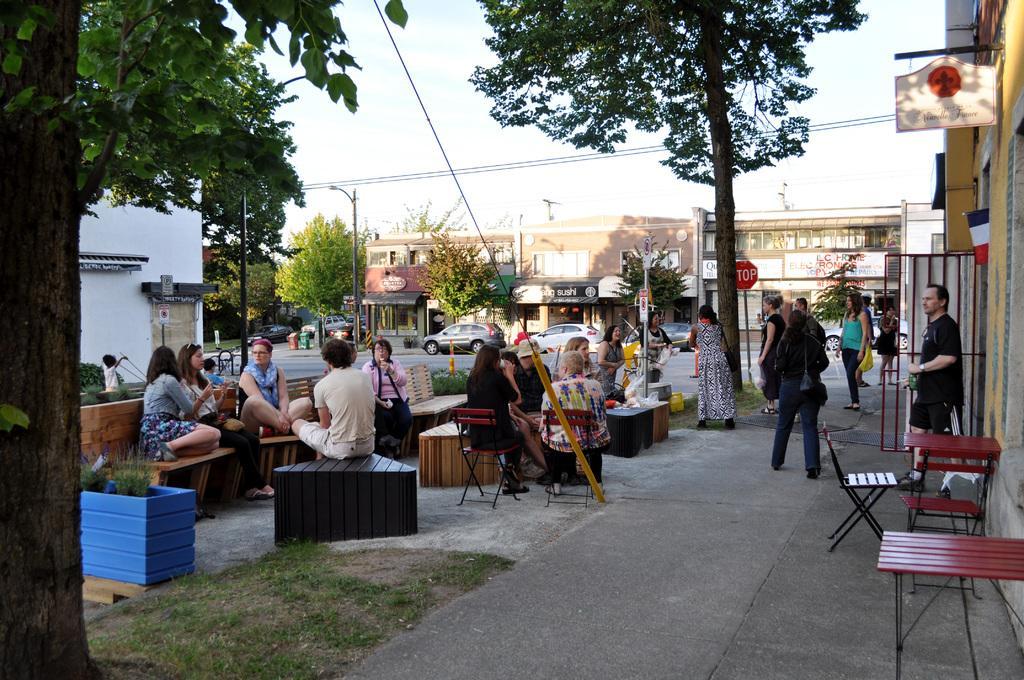How would you summarize this image in a sentence or two? In this image we can see men,women are sitting and standing. Right side of the image one man is standing and table-chair is there. Background of the image trees, buildings, cars and poles are there. Left side of the image one tree and plants are there. At the top of the image sky is present. 